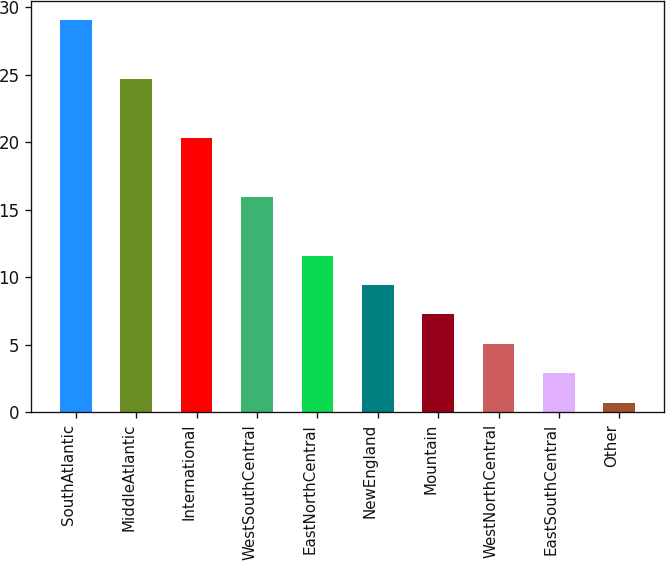Convert chart. <chart><loc_0><loc_0><loc_500><loc_500><bar_chart><fcel>SouthAtlantic<fcel>MiddleAtlantic<fcel>International<fcel>WestSouthCentral<fcel>EastNorthCentral<fcel>NewEngland<fcel>Mountain<fcel>WestNorthCentral<fcel>EastSouthCentral<fcel>Other<nl><fcel>29.04<fcel>24.68<fcel>20.32<fcel>15.96<fcel>11.6<fcel>9.42<fcel>7.24<fcel>5.06<fcel>2.88<fcel>0.7<nl></chart> 